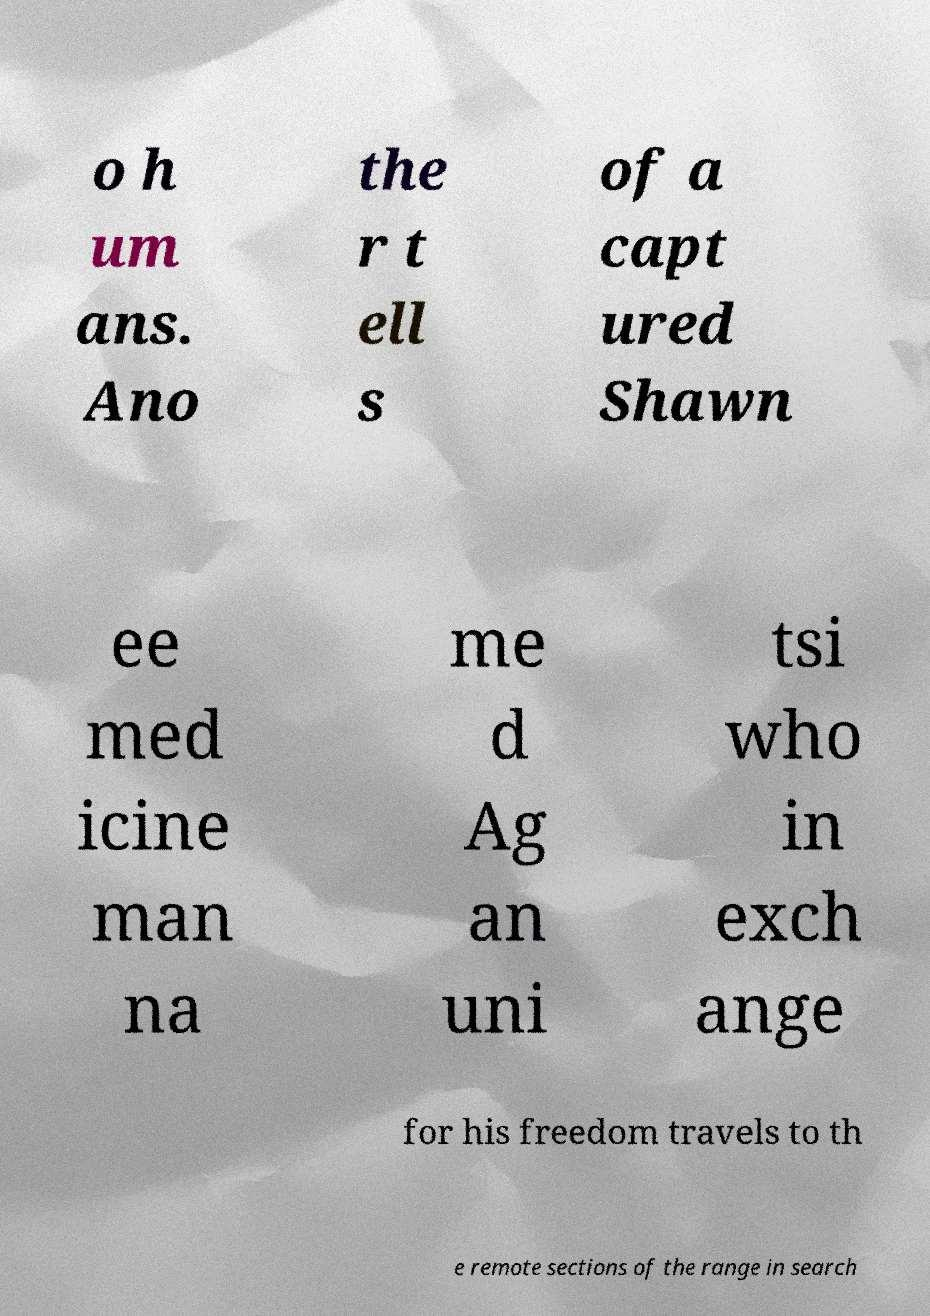Could you extract and type out the text from this image? o h um ans. Ano the r t ell s of a capt ured Shawn ee med icine man na me d Ag an uni tsi who in exch ange for his freedom travels to th e remote sections of the range in search 